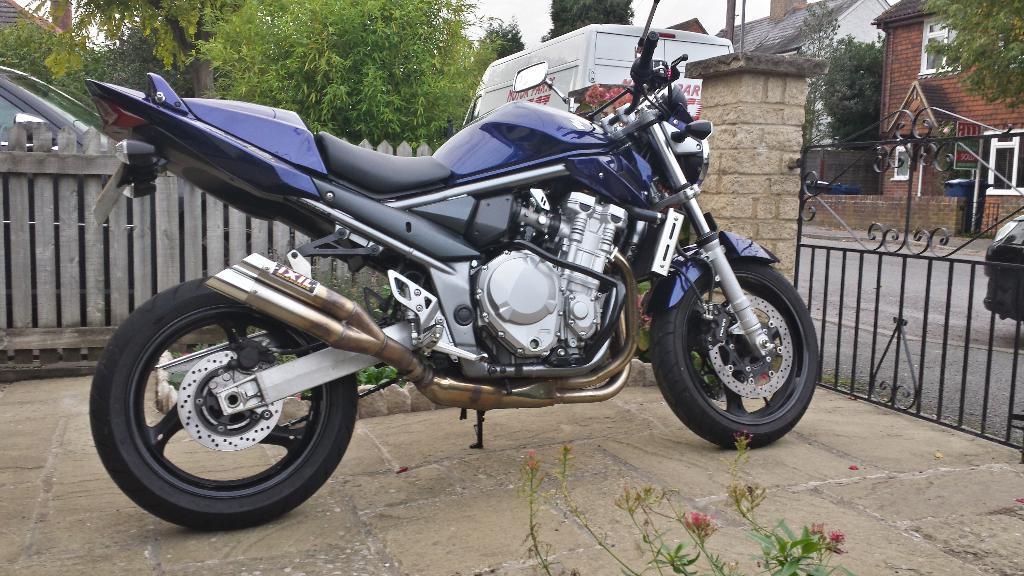Could you give a brief overview of what you see in this image? In this picture there is motorbike in the foreground. At the back there are vehicles behind the railing and there are trees and buildings. On the right side of the image there is a gate. At top there is sky. In the foreground there are flowers on the plant. 